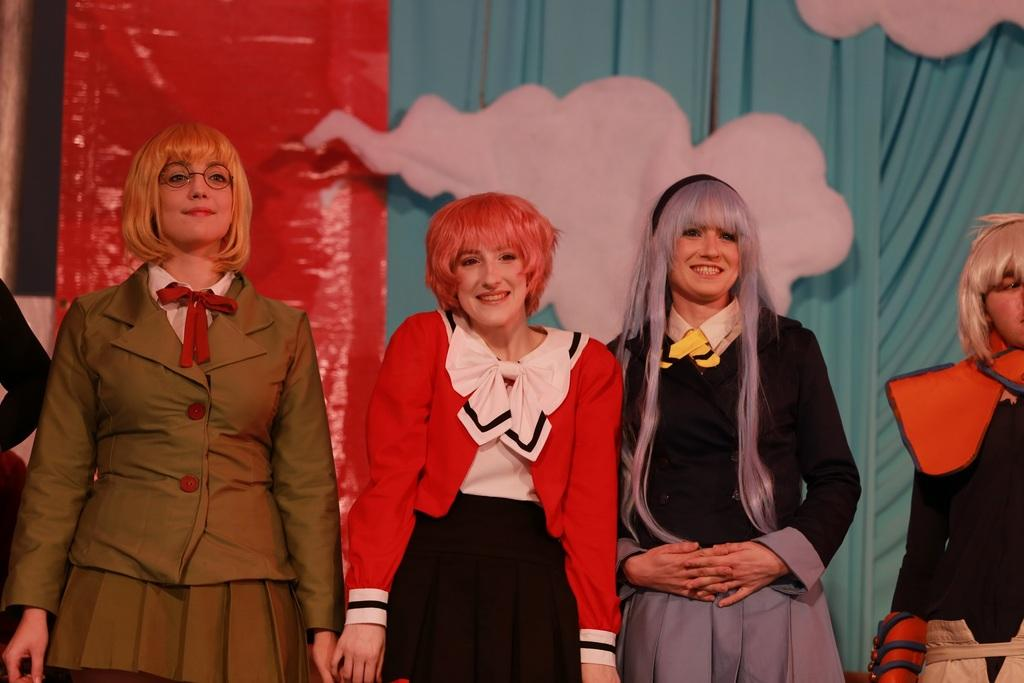How many women are in the image? There are four women in the image. What are the women doing in the image? The women are standing and smiling. What are the women wearing in the image? The women are wearing different costumes. What can be seen in the background of the image? There is a blue curtain in the background of the image. How is the blue curtain decorated? The blue curtain is decorated. Can you tell me how many monkeys are sitting on the bed in the image? There are no monkeys or beds present in the image. What thoughts are going through the women's minds in the image? We cannot determine the thoughts of the women in the image based on the provided facts. 